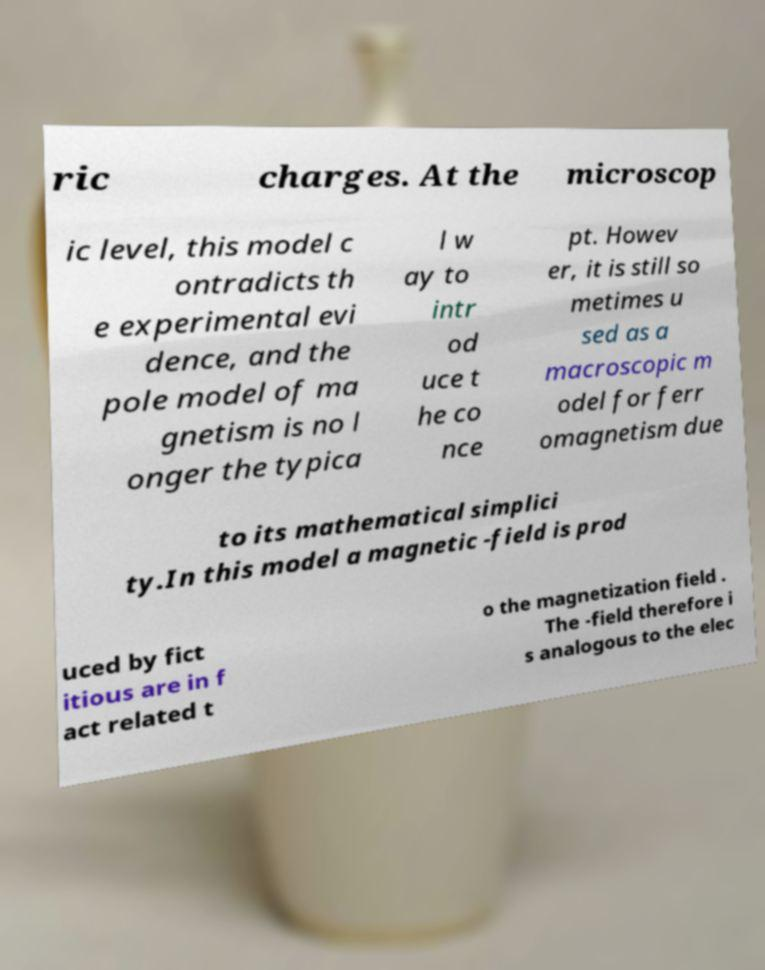Could you assist in decoding the text presented in this image and type it out clearly? ric charges. At the microscop ic level, this model c ontradicts th e experimental evi dence, and the pole model of ma gnetism is no l onger the typica l w ay to intr od uce t he co nce pt. Howev er, it is still so metimes u sed as a macroscopic m odel for ferr omagnetism due to its mathematical simplici ty.In this model a magnetic -field is prod uced by fict itious are in f act related t o the magnetization field . The -field therefore i s analogous to the elec 